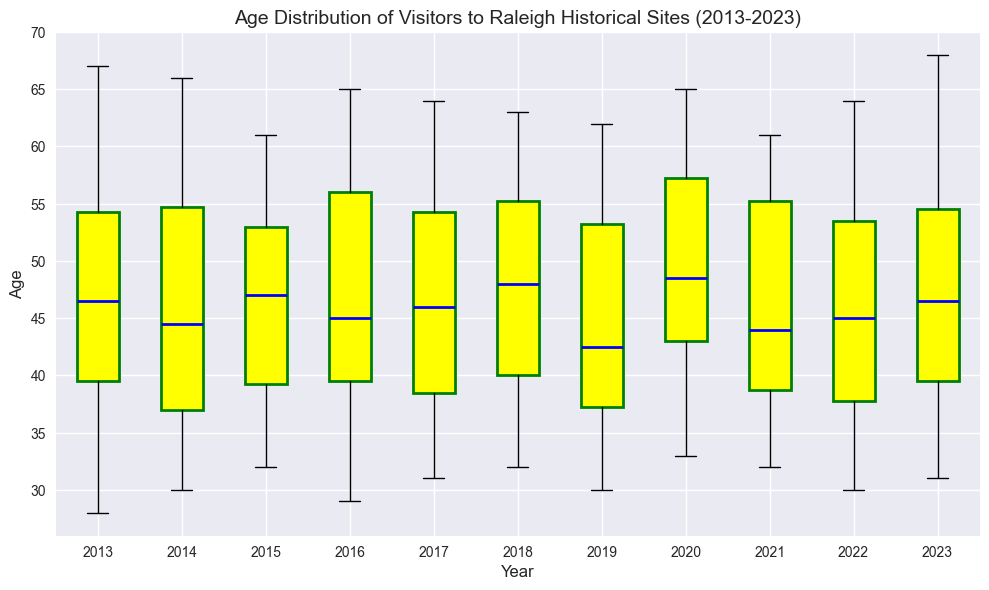What's the median age of visitors in 2020? To find the median age for 2020, locate the box for the year 2020 and identify the line inside the box. The line represents the median value.
Answer: 50 Which year had the oldest visitor? To identify the year with the oldest visitor, look for the highest point among all the whiskers in the box plot.
Answer: 2023 Was there a year when the median age dropped below 40? To determine this, find the boxes' median lines and check if any year has its median line below the age of 40. No median line appears below 40, so the answer is no.
Answer: No In which year was the age range of visitors widest? To find the widest age range, compare the lengths of the whiskers (vertical lines) for each year and identify the year with the largest distance between the top and bottom whiskers.
Answer: 2023 Is the overall trend in the median age of visitors increasing or decreasing over the decade? Observe the median lines for each year from 2013 to 2023. Check if they generally ascend or descend. The median values appear to remain relatively consistent, with minor fluctuations, suggesting no clear increasing or decreasing trend.
Answer: Neither Which year has the smallest interquartile range (IQR) for the visitors' age? The IQR is represented by the height of the box. The smallest box height among the years indicates the smallest IQR. By visually inspecting, 2022 has the smallest IQR.
Answer: 2022 How many years have the median age above 50? Look at the boxes and count how many have their median line (blue) above the age of 50 (represented on the y-axis). The years 2016, 2017, 2018, 2019, 2020, and 2021 have the median age above 50, which counts as 6 years.
Answer: 6 For which year are there noticeable outliers in visitor ages? Outliers are represented by distinct dots outside the whiskers of the box plots. Look at the years with such dots. The years 2015, 2017, 2018, and 2023 have visible outliers.
Answer: 2015, 2017, 2018, 2023 What colors are used for the box and median line in the box plot? Identify the colors used in the plot visually. The boxes are filled with yellow, and the median lines are blue.
Answer: Yellow (boxes), Blue (median lines) How does the variability in visitor age in 2020 compare to 2013? Compare the length of the whiskers and the height of the boxes for the years 2020 and 2013. The longer whiskers and taller boxes indicate higher variability. By comparing both, the 2020 box plot shows greater variability than the one in 2013.
Answer: 2020 has greater variability 